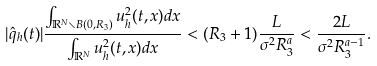Convert formula to latex. <formula><loc_0><loc_0><loc_500><loc_500>| \hat { q } _ { h } ( t ) | \frac { \int _ { \mathbb { R } ^ { N } \smallsetminus B ( 0 , R _ { 3 } ) } u _ { h } ^ { 2 } ( t , x ) d x } { \int _ { \mathbb { R } ^ { N } } u _ { h } ^ { 2 } ( t , x ) d x } < ( R _ { 3 } + 1 ) \frac { L } { \sigma ^ { 2 } R _ { 3 } ^ { a } } < \frac { 2 L } { \sigma ^ { 2 } R _ { 3 } ^ { a - 1 } } .</formula> 